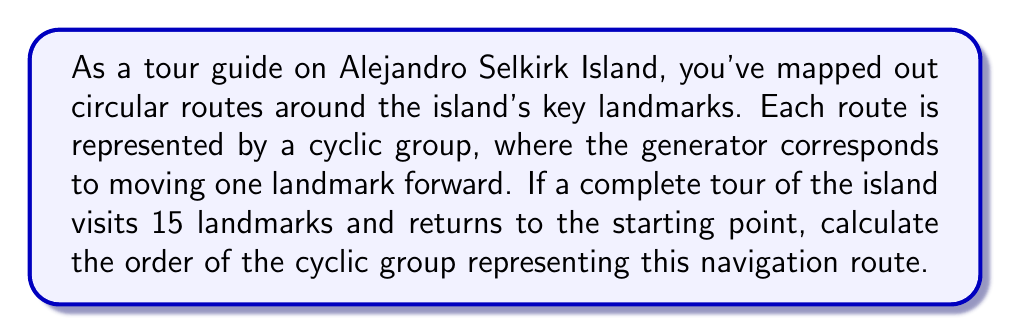Solve this math problem. To solve this problem, we need to understand the properties of cyclic groups and how they relate to the given scenario:

1) In a cyclic group, all elements can be generated by repeatedly applying the generator element.

2) The order of a cyclic group is the smallest positive integer $n$ such that $g^n = e$, where $g$ is the generator and $e$ is the identity element.

3) In our case, the generator represents moving from one landmark to the next, and a complete tour returns to the starting point after visiting all landmarks.

4) The number of landmarks visited before returning to the start point is 15.

5) This means that applying the generator 15 times (i.e., moving forward 15 landmarks) brings us back to the starting point.

6) In group theory notation, this can be written as $g^{15} = e$, where $g$ is the generator (moving one landmark forward) and $e$ is the identity element (being at the starting point).

7) By definition, the smallest positive integer that satisfies this equation is the order of the cyclic group.

Therefore, the order of the cyclic group representing this navigation route is 15.

This can be denoted mathematically as:

$$|\langle g \rangle| = 15$$

where $\langle g \rangle$ represents the cyclic group generated by $g$.
Answer: The order of the cyclic group representing the island navigation route is 15. 